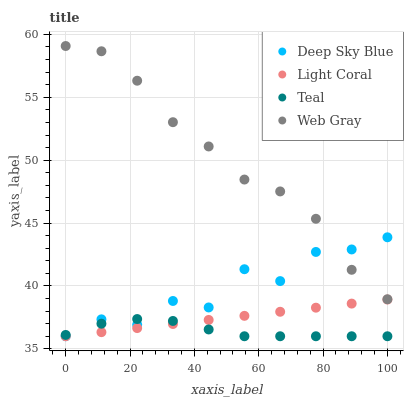Does Teal have the minimum area under the curve?
Answer yes or no. Yes. Does Web Gray have the maximum area under the curve?
Answer yes or no. Yes. Does Web Gray have the minimum area under the curve?
Answer yes or no. No. Does Teal have the maximum area under the curve?
Answer yes or no. No. Is Light Coral the smoothest?
Answer yes or no. Yes. Is Deep Sky Blue the roughest?
Answer yes or no. Yes. Is Web Gray the smoothest?
Answer yes or no. No. Is Web Gray the roughest?
Answer yes or no. No. Does Light Coral have the lowest value?
Answer yes or no. Yes. Does Web Gray have the lowest value?
Answer yes or no. No. Does Web Gray have the highest value?
Answer yes or no. Yes. Does Teal have the highest value?
Answer yes or no. No. Is Light Coral less than Web Gray?
Answer yes or no. Yes. Is Web Gray greater than Light Coral?
Answer yes or no. Yes. Does Web Gray intersect Deep Sky Blue?
Answer yes or no. Yes. Is Web Gray less than Deep Sky Blue?
Answer yes or no. No. Is Web Gray greater than Deep Sky Blue?
Answer yes or no. No. Does Light Coral intersect Web Gray?
Answer yes or no. No. 